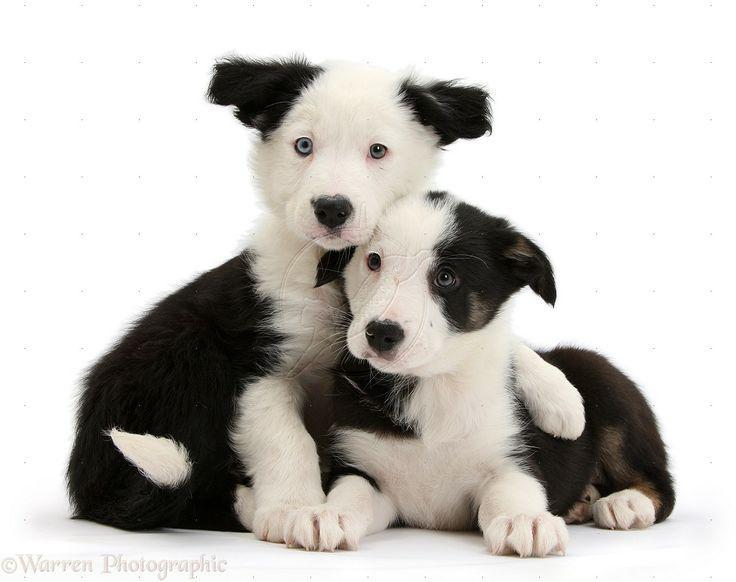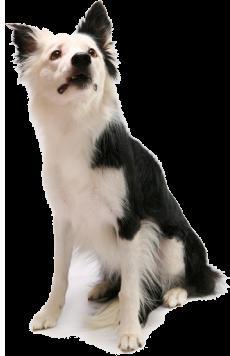The first image is the image on the left, the second image is the image on the right. Given the left and right images, does the statement "The combined images contain three dogs, and in one image, a black-and-white dog sits upright and all alone." hold true? Answer yes or no. Yes. The first image is the image on the left, the second image is the image on the right. Given the left and right images, does the statement "There is exactly two dogs in the right image." hold true? Answer yes or no. No. 